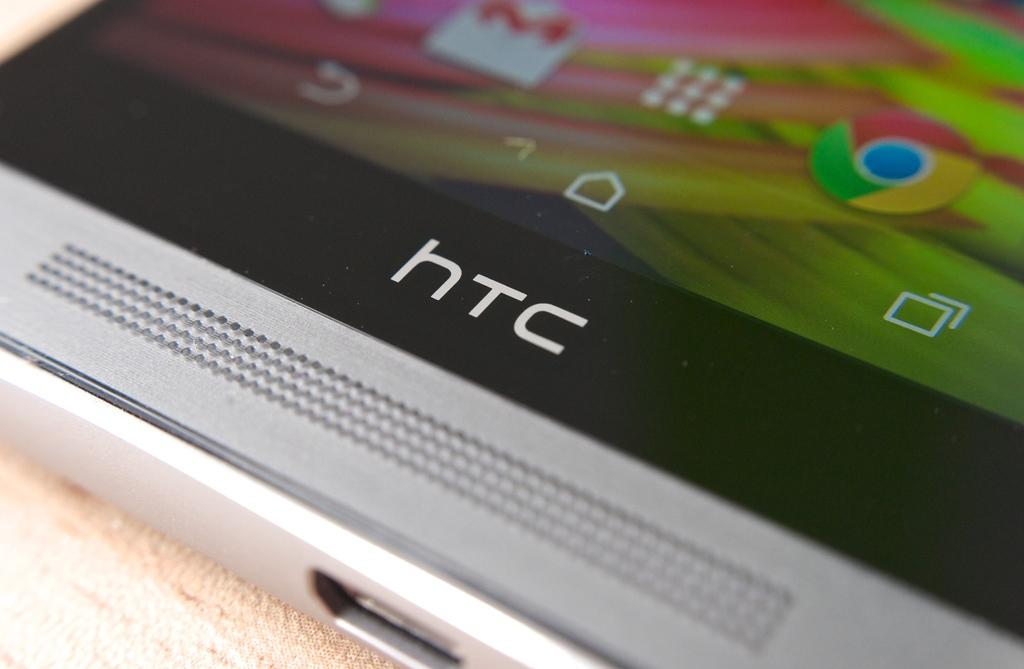<image>
Share a concise interpretation of the image provided. an extreme close up of an HTC silver cell phone 